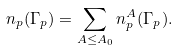<formula> <loc_0><loc_0><loc_500><loc_500>n _ { p } ( \Gamma _ { p } ) = \sum _ { A \leq A _ { 0 } } n _ { p } ^ { A } ( \Gamma _ { p } ) .</formula> 